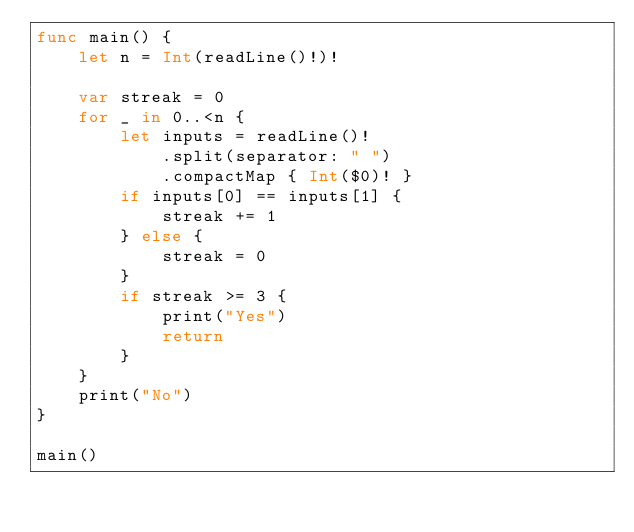Convert code to text. <code><loc_0><loc_0><loc_500><loc_500><_Swift_>func main() {
    let n = Int(readLine()!)!
    
    var streak = 0
    for _ in 0..<n {
        let inputs = readLine()!
            .split(separator: " ")
            .compactMap { Int($0)! }
        if inputs[0] == inputs[1] {
            streak += 1
        } else {
            streak = 0
        }
        if streak >= 3 {
            print("Yes")
            return
        }
    }
    print("No")
}

main()
</code> 